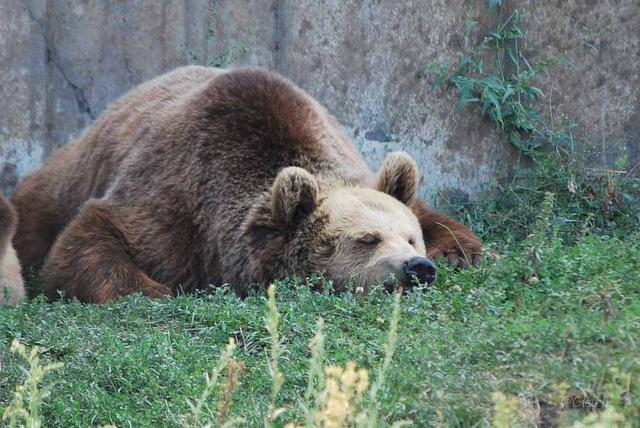What are they laying atop?
Concise answer only. Grass. What type of bear is this?
Write a very short answer. Grizzly. Is this bear in the wild?
Write a very short answer. No. What is the bear doing?
Answer briefly. Sleeping. Is the bear vocalizing?
Write a very short answer. No. Is this animal sleeping?
Keep it brief. Yes. Does the animal look wet?
Keep it brief. No. Is this a rocky area?
Keep it brief. Yes. 